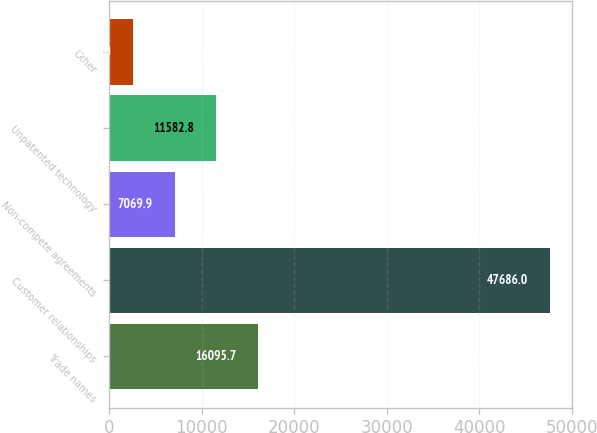Convert chart to OTSL. <chart><loc_0><loc_0><loc_500><loc_500><bar_chart><fcel>Trade names<fcel>Customer relationships<fcel>Non-compete agreements<fcel>Unpatented technology<fcel>Other<nl><fcel>16095.7<fcel>47686<fcel>7069.9<fcel>11582.8<fcel>2557<nl></chart> 